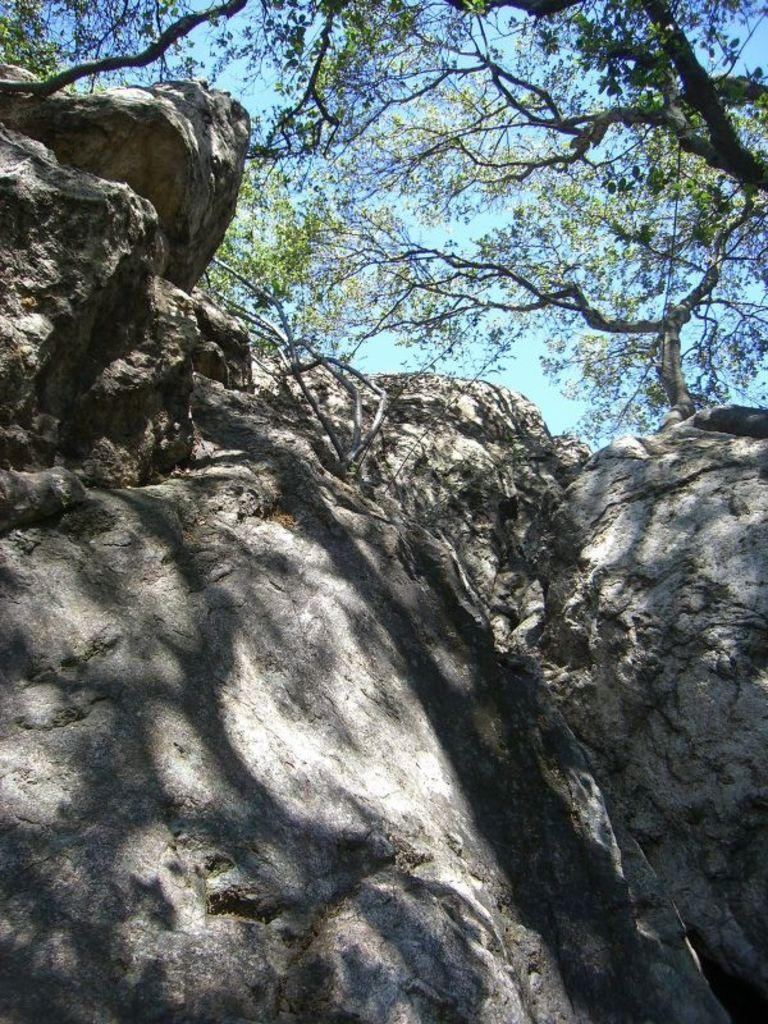What type of landscape feature is present in the image? There is a hill in the image. What other natural elements can be seen in the image? There are trees in the image. What can be seen in the background of the image? The sky is visible in the background of the image. What type of acoustics can be heard from the playground in the image? There is no playground present in the image, so it is not possible to determine the acoustics. 